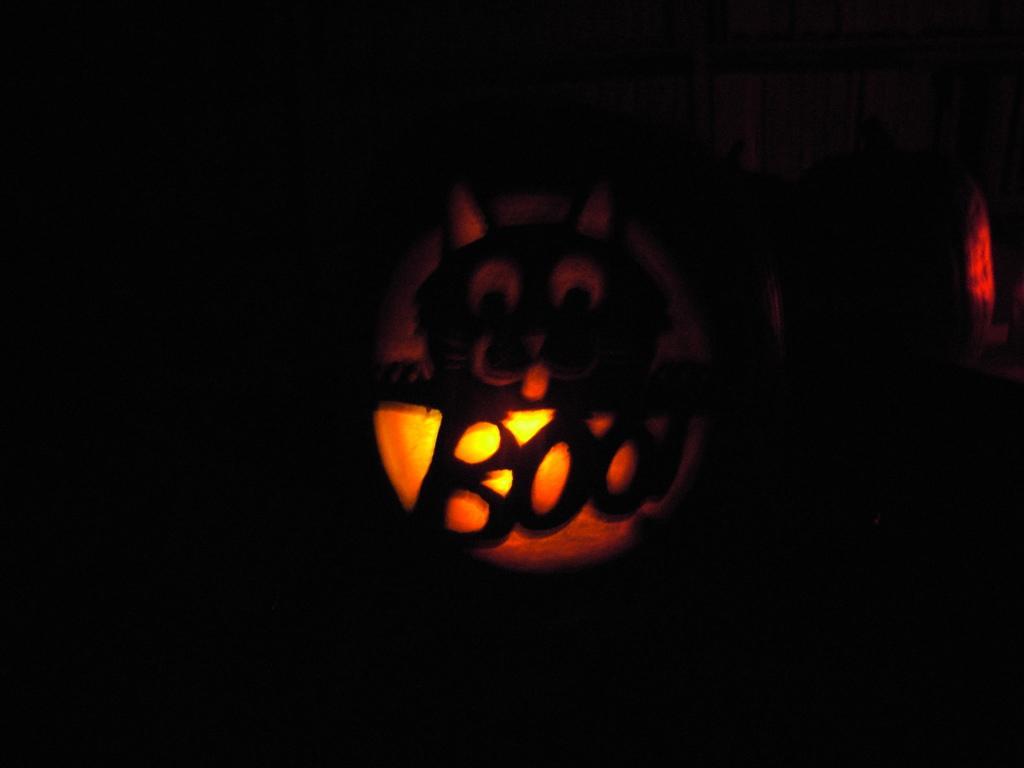Can you describe this image briefly? In this picture we can see a light in the dark background. 